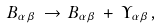Convert formula to latex. <formula><loc_0><loc_0><loc_500><loc_500>B _ { \alpha \beta } \, \rightarrow \, B _ { \alpha \beta } \, + \, \Upsilon _ { \alpha \beta } ,</formula> 